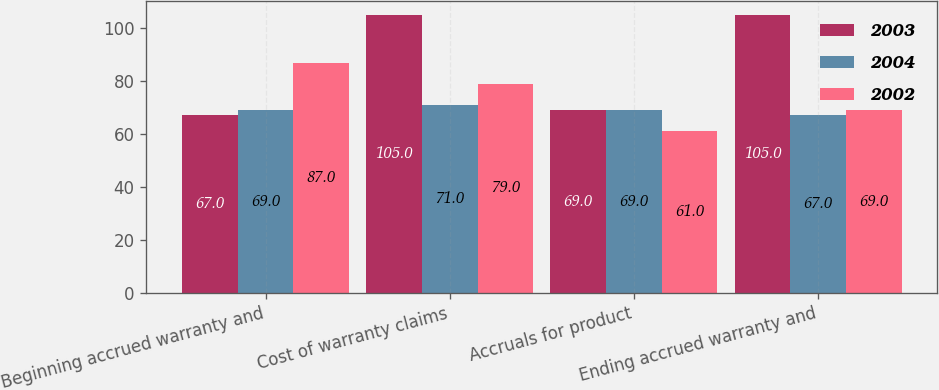Convert chart to OTSL. <chart><loc_0><loc_0><loc_500><loc_500><stacked_bar_chart><ecel><fcel>Beginning accrued warranty and<fcel>Cost of warranty claims<fcel>Accruals for product<fcel>Ending accrued warranty and<nl><fcel>2003<fcel>67<fcel>105<fcel>69<fcel>105<nl><fcel>2004<fcel>69<fcel>71<fcel>69<fcel>67<nl><fcel>2002<fcel>87<fcel>79<fcel>61<fcel>69<nl></chart> 